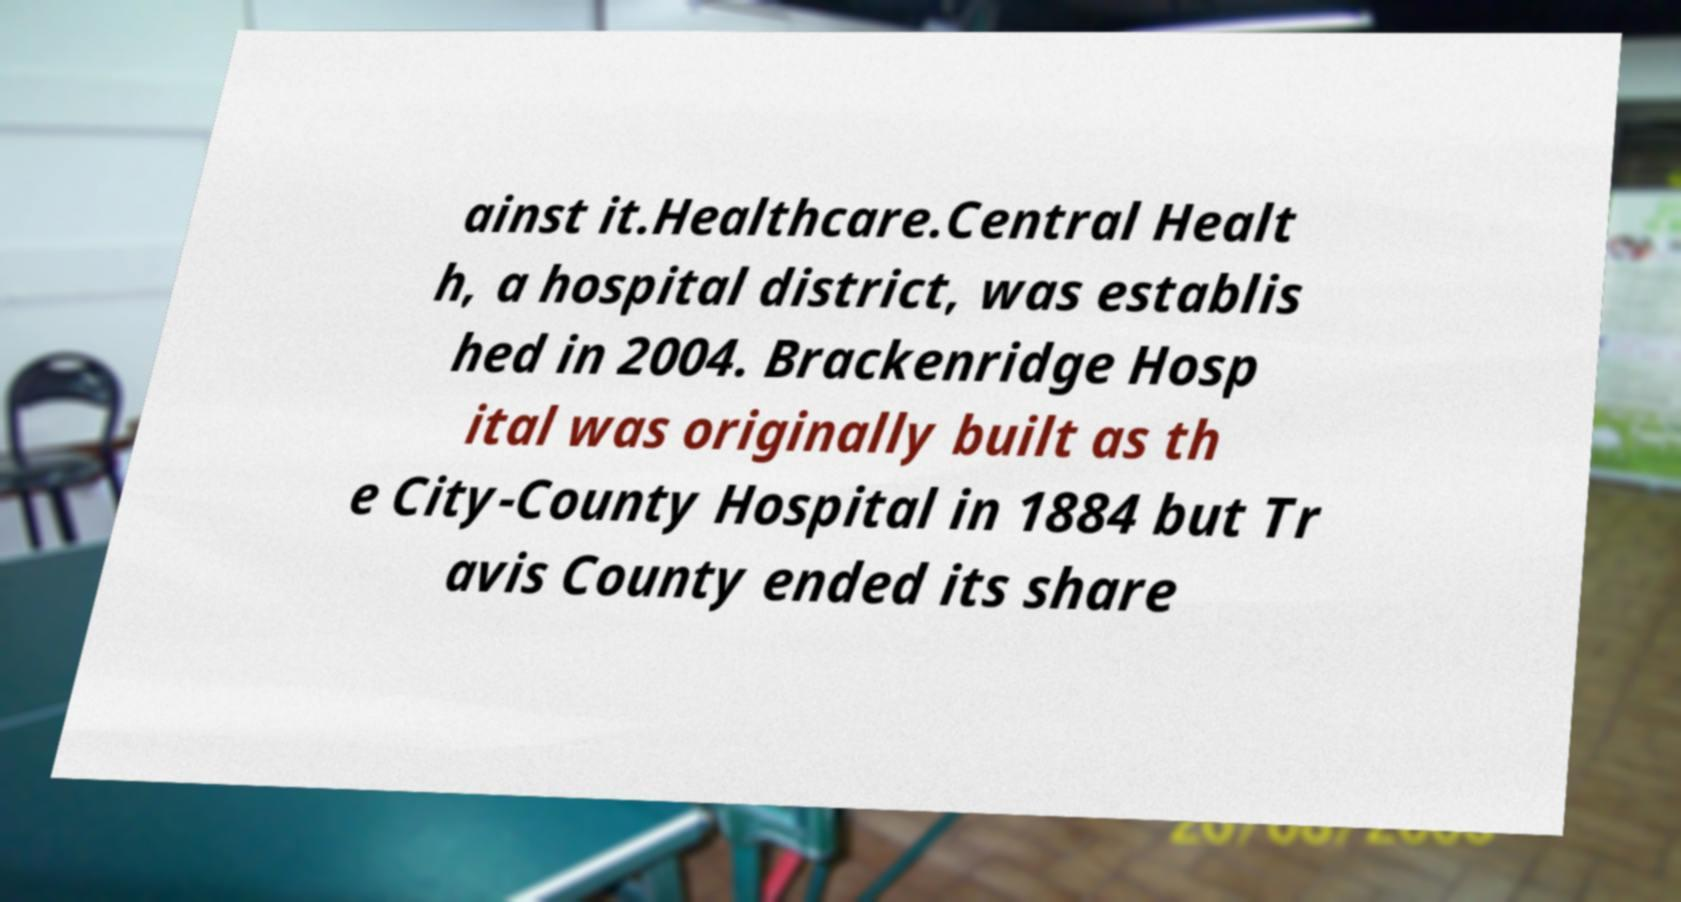Please identify and transcribe the text found in this image. ainst it.Healthcare.Central Healt h, a hospital district, was establis hed in 2004. Brackenridge Hosp ital was originally built as th e City-County Hospital in 1884 but Tr avis County ended its share 